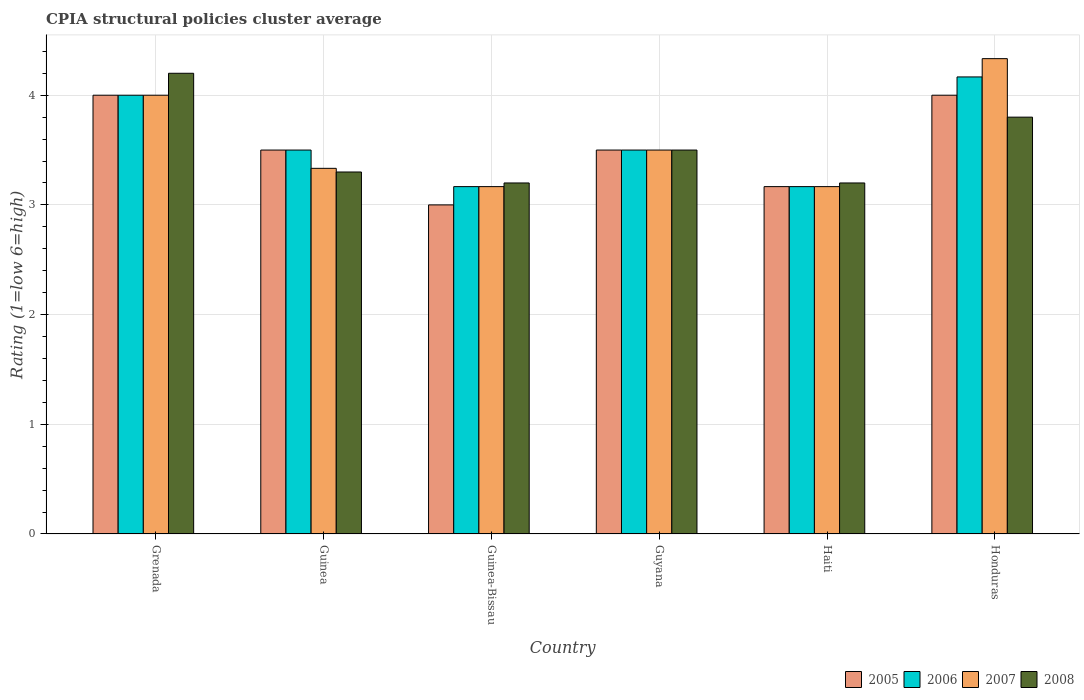How many groups of bars are there?
Your response must be concise. 6. Are the number of bars per tick equal to the number of legend labels?
Provide a succinct answer. Yes. Are the number of bars on each tick of the X-axis equal?
Provide a succinct answer. Yes. How many bars are there on the 5th tick from the left?
Make the answer very short. 4. How many bars are there on the 5th tick from the right?
Ensure brevity in your answer.  4. What is the label of the 3rd group of bars from the left?
Make the answer very short. Guinea-Bissau. In how many cases, is the number of bars for a given country not equal to the number of legend labels?
Make the answer very short. 0. What is the CPIA rating in 2005 in Grenada?
Your answer should be compact. 4. Across all countries, what is the minimum CPIA rating in 2007?
Give a very brief answer. 3.17. In which country was the CPIA rating in 2006 maximum?
Your response must be concise. Honduras. In which country was the CPIA rating in 2007 minimum?
Give a very brief answer. Guinea-Bissau. What is the total CPIA rating in 2005 in the graph?
Provide a short and direct response. 21.17. What is the difference between the CPIA rating in 2007 in Guinea and that in Honduras?
Provide a succinct answer. -1. What is the average CPIA rating in 2005 per country?
Offer a very short reply. 3.53. What is the difference between the CPIA rating of/in 2005 and CPIA rating of/in 2007 in Honduras?
Provide a succinct answer. -0.33. In how many countries, is the CPIA rating in 2006 greater than 2.6?
Make the answer very short. 6. What is the ratio of the CPIA rating in 2005 in Guinea-Bissau to that in Haiti?
Your answer should be very brief. 0.95. Is the CPIA rating in 2007 in Grenada less than that in Honduras?
Make the answer very short. Yes. Is the difference between the CPIA rating in 2005 in Guyana and Haiti greater than the difference between the CPIA rating in 2007 in Guyana and Haiti?
Offer a terse response. No. What is the difference between the highest and the second highest CPIA rating in 2008?
Offer a very short reply. -0.3. What is the difference between the highest and the lowest CPIA rating in 2007?
Offer a terse response. 1.17. In how many countries, is the CPIA rating in 2006 greater than the average CPIA rating in 2006 taken over all countries?
Give a very brief answer. 2. What does the 2nd bar from the left in Guyana represents?
Ensure brevity in your answer.  2006. Is it the case that in every country, the sum of the CPIA rating in 2005 and CPIA rating in 2006 is greater than the CPIA rating in 2008?
Your answer should be compact. Yes. How many bars are there?
Ensure brevity in your answer.  24. Are all the bars in the graph horizontal?
Offer a very short reply. No. How many countries are there in the graph?
Ensure brevity in your answer.  6. Are the values on the major ticks of Y-axis written in scientific E-notation?
Offer a terse response. No. Does the graph contain any zero values?
Provide a succinct answer. No. Does the graph contain grids?
Ensure brevity in your answer.  Yes. How are the legend labels stacked?
Your answer should be very brief. Horizontal. What is the title of the graph?
Your response must be concise. CPIA structural policies cluster average. What is the label or title of the X-axis?
Your answer should be very brief. Country. What is the Rating (1=low 6=high) in 2006 in Grenada?
Provide a short and direct response. 4. What is the Rating (1=low 6=high) of 2007 in Grenada?
Provide a succinct answer. 4. What is the Rating (1=low 6=high) in 2007 in Guinea?
Your answer should be compact. 3.33. What is the Rating (1=low 6=high) of 2005 in Guinea-Bissau?
Provide a succinct answer. 3. What is the Rating (1=low 6=high) in 2006 in Guinea-Bissau?
Provide a succinct answer. 3.17. What is the Rating (1=low 6=high) of 2007 in Guinea-Bissau?
Your response must be concise. 3.17. What is the Rating (1=low 6=high) of 2006 in Guyana?
Provide a succinct answer. 3.5. What is the Rating (1=low 6=high) of 2005 in Haiti?
Give a very brief answer. 3.17. What is the Rating (1=low 6=high) of 2006 in Haiti?
Ensure brevity in your answer.  3.17. What is the Rating (1=low 6=high) in 2007 in Haiti?
Keep it short and to the point. 3.17. What is the Rating (1=low 6=high) in 2008 in Haiti?
Your answer should be compact. 3.2. What is the Rating (1=low 6=high) in 2005 in Honduras?
Make the answer very short. 4. What is the Rating (1=low 6=high) of 2006 in Honduras?
Ensure brevity in your answer.  4.17. What is the Rating (1=low 6=high) of 2007 in Honduras?
Offer a terse response. 4.33. What is the Rating (1=low 6=high) in 2008 in Honduras?
Keep it short and to the point. 3.8. Across all countries, what is the maximum Rating (1=low 6=high) of 2005?
Provide a succinct answer. 4. Across all countries, what is the maximum Rating (1=low 6=high) of 2006?
Ensure brevity in your answer.  4.17. Across all countries, what is the maximum Rating (1=low 6=high) of 2007?
Your answer should be very brief. 4.33. Across all countries, what is the maximum Rating (1=low 6=high) of 2008?
Ensure brevity in your answer.  4.2. Across all countries, what is the minimum Rating (1=low 6=high) of 2005?
Offer a very short reply. 3. Across all countries, what is the minimum Rating (1=low 6=high) in 2006?
Make the answer very short. 3.17. Across all countries, what is the minimum Rating (1=low 6=high) in 2007?
Offer a very short reply. 3.17. What is the total Rating (1=low 6=high) in 2005 in the graph?
Keep it short and to the point. 21.17. What is the total Rating (1=low 6=high) in 2006 in the graph?
Your answer should be compact. 21.5. What is the total Rating (1=low 6=high) of 2007 in the graph?
Provide a short and direct response. 21.5. What is the total Rating (1=low 6=high) in 2008 in the graph?
Your answer should be very brief. 21.2. What is the difference between the Rating (1=low 6=high) of 2005 in Grenada and that in Guinea?
Offer a very short reply. 0.5. What is the difference between the Rating (1=low 6=high) in 2007 in Grenada and that in Guinea?
Offer a very short reply. 0.67. What is the difference between the Rating (1=low 6=high) of 2008 in Grenada and that in Guinea?
Give a very brief answer. 0.9. What is the difference between the Rating (1=low 6=high) in 2005 in Grenada and that in Guinea-Bissau?
Provide a succinct answer. 1. What is the difference between the Rating (1=low 6=high) in 2007 in Grenada and that in Guinea-Bissau?
Your answer should be compact. 0.83. What is the difference between the Rating (1=low 6=high) of 2005 in Grenada and that in Guyana?
Provide a succinct answer. 0.5. What is the difference between the Rating (1=low 6=high) of 2008 in Grenada and that in Guyana?
Your response must be concise. 0.7. What is the difference between the Rating (1=low 6=high) of 2005 in Grenada and that in Haiti?
Offer a terse response. 0.83. What is the difference between the Rating (1=low 6=high) of 2006 in Grenada and that in Haiti?
Provide a succinct answer. 0.83. What is the difference between the Rating (1=low 6=high) in 2007 in Grenada and that in Haiti?
Provide a succinct answer. 0.83. What is the difference between the Rating (1=low 6=high) of 2008 in Grenada and that in Honduras?
Your answer should be very brief. 0.4. What is the difference between the Rating (1=low 6=high) of 2005 in Guinea and that in Guinea-Bissau?
Your answer should be very brief. 0.5. What is the difference between the Rating (1=low 6=high) in 2006 in Guinea and that in Guinea-Bissau?
Keep it short and to the point. 0.33. What is the difference between the Rating (1=low 6=high) of 2006 in Guinea and that in Guyana?
Provide a succinct answer. 0. What is the difference between the Rating (1=low 6=high) of 2007 in Guinea and that in Guyana?
Give a very brief answer. -0.17. What is the difference between the Rating (1=low 6=high) in 2005 in Guinea and that in Haiti?
Offer a very short reply. 0.33. What is the difference between the Rating (1=low 6=high) in 2006 in Guinea and that in Haiti?
Provide a succinct answer. 0.33. What is the difference between the Rating (1=low 6=high) in 2007 in Guinea and that in Haiti?
Your response must be concise. 0.17. What is the difference between the Rating (1=low 6=high) in 2005 in Guinea and that in Honduras?
Keep it short and to the point. -0.5. What is the difference between the Rating (1=low 6=high) of 2005 in Guinea-Bissau and that in Guyana?
Make the answer very short. -0.5. What is the difference between the Rating (1=low 6=high) of 2007 in Guinea-Bissau and that in Guyana?
Your response must be concise. -0.33. What is the difference between the Rating (1=low 6=high) in 2006 in Guinea-Bissau and that in Haiti?
Offer a very short reply. 0. What is the difference between the Rating (1=low 6=high) in 2007 in Guinea-Bissau and that in Haiti?
Provide a succinct answer. 0. What is the difference between the Rating (1=low 6=high) in 2005 in Guinea-Bissau and that in Honduras?
Ensure brevity in your answer.  -1. What is the difference between the Rating (1=low 6=high) of 2006 in Guinea-Bissau and that in Honduras?
Offer a very short reply. -1. What is the difference between the Rating (1=low 6=high) in 2007 in Guinea-Bissau and that in Honduras?
Ensure brevity in your answer.  -1.17. What is the difference between the Rating (1=low 6=high) in 2008 in Guinea-Bissau and that in Honduras?
Your answer should be very brief. -0.6. What is the difference between the Rating (1=low 6=high) in 2005 in Guyana and that in Haiti?
Your answer should be very brief. 0.33. What is the difference between the Rating (1=low 6=high) in 2007 in Guyana and that in Haiti?
Make the answer very short. 0.33. What is the difference between the Rating (1=low 6=high) in 2005 in Haiti and that in Honduras?
Ensure brevity in your answer.  -0.83. What is the difference between the Rating (1=low 6=high) in 2006 in Haiti and that in Honduras?
Keep it short and to the point. -1. What is the difference between the Rating (1=low 6=high) in 2007 in Haiti and that in Honduras?
Provide a succinct answer. -1.17. What is the difference between the Rating (1=low 6=high) of 2005 in Grenada and the Rating (1=low 6=high) of 2007 in Guinea?
Give a very brief answer. 0.67. What is the difference between the Rating (1=low 6=high) of 2007 in Grenada and the Rating (1=low 6=high) of 2008 in Guinea?
Offer a very short reply. 0.7. What is the difference between the Rating (1=low 6=high) in 2005 in Grenada and the Rating (1=low 6=high) in 2006 in Guinea-Bissau?
Offer a terse response. 0.83. What is the difference between the Rating (1=low 6=high) in 2005 in Grenada and the Rating (1=low 6=high) in 2008 in Guinea-Bissau?
Ensure brevity in your answer.  0.8. What is the difference between the Rating (1=low 6=high) of 2006 in Grenada and the Rating (1=low 6=high) of 2008 in Guinea-Bissau?
Your answer should be compact. 0.8. What is the difference between the Rating (1=low 6=high) in 2005 in Grenada and the Rating (1=low 6=high) in 2006 in Guyana?
Provide a short and direct response. 0.5. What is the difference between the Rating (1=low 6=high) of 2005 in Grenada and the Rating (1=low 6=high) of 2008 in Guyana?
Offer a terse response. 0.5. What is the difference between the Rating (1=low 6=high) in 2005 in Grenada and the Rating (1=low 6=high) in 2008 in Haiti?
Provide a short and direct response. 0.8. What is the difference between the Rating (1=low 6=high) of 2006 in Grenada and the Rating (1=low 6=high) of 2008 in Haiti?
Offer a terse response. 0.8. What is the difference between the Rating (1=low 6=high) of 2006 in Grenada and the Rating (1=low 6=high) of 2007 in Honduras?
Give a very brief answer. -0.33. What is the difference between the Rating (1=low 6=high) in 2006 in Grenada and the Rating (1=low 6=high) in 2008 in Honduras?
Your answer should be compact. 0.2. What is the difference between the Rating (1=low 6=high) in 2007 in Grenada and the Rating (1=low 6=high) in 2008 in Honduras?
Your answer should be compact. 0.2. What is the difference between the Rating (1=low 6=high) of 2005 in Guinea and the Rating (1=low 6=high) of 2006 in Guinea-Bissau?
Your answer should be very brief. 0.33. What is the difference between the Rating (1=low 6=high) in 2005 in Guinea and the Rating (1=low 6=high) in 2007 in Guinea-Bissau?
Your response must be concise. 0.33. What is the difference between the Rating (1=low 6=high) in 2005 in Guinea and the Rating (1=low 6=high) in 2008 in Guinea-Bissau?
Your response must be concise. 0.3. What is the difference between the Rating (1=low 6=high) of 2006 in Guinea and the Rating (1=low 6=high) of 2007 in Guinea-Bissau?
Your answer should be compact. 0.33. What is the difference between the Rating (1=low 6=high) of 2006 in Guinea and the Rating (1=low 6=high) of 2008 in Guinea-Bissau?
Your answer should be compact. 0.3. What is the difference between the Rating (1=low 6=high) in 2007 in Guinea and the Rating (1=low 6=high) in 2008 in Guinea-Bissau?
Make the answer very short. 0.13. What is the difference between the Rating (1=low 6=high) in 2006 in Guinea and the Rating (1=low 6=high) in 2008 in Guyana?
Your answer should be very brief. 0. What is the difference between the Rating (1=low 6=high) of 2007 in Guinea and the Rating (1=low 6=high) of 2008 in Guyana?
Your answer should be compact. -0.17. What is the difference between the Rating (1=low 6=high) in 2005 in Guinea and the Rating (1=low 6=high) in 2007 in Haiti?
Your answer should be very brief. 0.33. What is the difference between the Rating (1=low 6=high) of 2005 in Guinea and the Rating (1=low 6=high) of 2008 in Haiti?
Your response must be concise. 0.3. What is the difference between the Rating (1=low 6=high) in 2006 in Guinea and the Rating (1=low 6=high) in 2007 in Haiti?
Offer a very short reply. 0.33. What is the difference between the Rating (1=low 6=high) of 2007 in Guinea and the Rating (1=low 6=high) of 2008 in Haiti?
Give a very brief answer. 0.13. What is the difference between the Rating (1=low 6=high) in 2005 in Guinea and the Rating (1=low 6=high) in 2006 in Honduras?
Your answer should be compact. -0.67. What is the difference between the Rating (1=low 6=high) of 2005 in Guinea and the Rating (1=low 6=high) of 2007 in Honduras?
Make the answer very short. -0.83. What is the difference between the Rating (1=low 6=high) of 2005 in Guinea and the Rating (1=low 6=high) of 2008 in Honduras?
Give a very brief answer. -0.3. What is the difference between the Rating (1=low 6=high) in 2006 in Guinea and the Rating (1=low 6=high) in 2008 in Honduras?
Offer a terse response. -0.3. What is the difference between the Rating (1=low 6=high) of 2007 in Guinea and the Rating (1=low 6=high) of 2008 in Honduras?
Provide a short and direct response. -0.47. What is the difference between the Rating (1=low 6=high) in 2005 in Guinea-Bissau and the Rating (1=low 6=high) in 2007 in Guyana?
Your answer should be compact. -0.5. What is the difference between the Rating (1=low 6=high) of 2006 in Guinea-Bissau and the Rating (1=low 6=high) of 2008 in Guyana?
Your response must be concise. -0.33. What is the difference between the Rating (1=low 6=high) in 2005 in Guinea-Bissau and the Rating (1=low 6=high) in 2007 in Haiti?
Make the answer very short. -0.17. What is the difference between the Rating (1=low 6=high) of 2006 in Guinea-Bissau and the Rating (1=low 6=high) of 2008 in Haiti?
Your answer should be very brief. -0.03. What is the difference between the Rating (1=low 6=high) in 2007 in Guinea-Bissau and the Rating (1=low 6=high) in 2008 in Haiti?
Provide a succinct answer. -0.03. What is the difference between the Rating (1=low 6=high) of 2005 in Guinea-Bissau and the Rating (1=low 6=high) of 2006 in Honduras?
Make the answer very short. -1.17. What is the difference between the Rating (1=low 6=high) of 2005 in Guinea-Bissau and the Rating (1=low 6=high) of 2007 in Honduras?
Ensure brevity in your answer.  -1.33. What is the difference between the Rating (1=low 6=high) of 2006 in Guinea-Bissau and the Rating (1=low 6=high) of 2007 in Honduras?
Your response must be concise. -1.17. What is the difference between the Rating (1=low 6=high) in 2006 in Guinea-Bissau and the Rating (1=low 6=high) in 2008 in Honduras?
Provide a succinct answer. -0.63. What is the difference between the Rating (1=low 6=high) in 2007 in Guinea-Bissau and the Rating (1=low 6=high) in 2008 in Honduras?
Keep it short and to the point. -0.63. What is the difference between the Rating (1=low 6=high) in 2005 in Guyana and the Rating (1=low 6=high) in 2006 in Haiti?
Provide a short and direct response. 0.33. What is the difference between the Rating (1=low 6=high) of 2005 in Guyana and the Rating (1=low 6=high) of 2007 in Haiti?
Your answer should be compact. 0.33. What is the difference between the Rating (1=low 6=high) in 2005 in Guyana and the Rating (1=low 6=high) in 2008 in Haiti?
Offer a very short reply. 0.3. What is the difference between the Rating (1=low 6=high) in 2006 in Guyana and the Rating (1=low 6=high) in 2007 in Haiti?
Ensure brevity in your answer.  0.33. What is the difference between the Rating (1=low 6=high) of 2005 in Guyana and the Rating (1=low 6=high) of 2007 in Honduras?
Your answer should be compact. -0.83. What is the difference between the Rating (1=low 6=high) in 2006 in Guyana and the Rating (1=low 6=high) in 2007 in Honduras?
Offer a terse response. -0.83. What is the difference between the Rating (1=low 6=high) in 2006 in Guyana and the Rating (1=low 6=high) in 2008 in Honduras?
Your answer should be very brief. -0.3. What is the difference between the Rating (1=low 6=high) of 2005 in Haiti and the Rating (1=low 6=high) of 2007 in Honduras?
Provide a succinct answer. -1.17. What is the difference between the Rating (1=low 6=high) in 2005 in Haiti and the Rating (1=low 6=high) in 2008 in Honduras?
Your response must be concise. -0.63. What is the difference between the Rating (1=low 6=high) in 2006 in Haiti and the Rating (1=low 6=high) in 2007 in Honduras?
Your response must be concise. -1.17. What is the difference between the Rating (1=low 6=high) of 2006 in Haiti and the Rating (1=low 6=high) of 2008 in Honduras?
Your answer should be compact. -0.63. What is the difference between the Rating (1=low 6=high) in 2007 in Haiti and the Rating (1=low 6=high) in 2008 in Honduras?
Offer a very short reply. -0.63. What is the average Rating (1=low 6=high) in 2005 per country?
Keep it short and to the point. 3.53. What is the average Rating (1=low 6=high) of 2006 per country?
Your response must be concise. 3.58. What is the average Rating (1=low 6=high) of 2007 per country?
Provide a short and direct response. 3.58. What is the average Rating (1=low 6=high) of 2008 per country?
Your answer should be compact. 3.53. What is the difference between the Rating (1=low 6=high) in 2005 and Rating (1=low 6=high) in 2007 in Grenada?
Your response must be concise. 0. What is the difference between the Rating (1=low 6=high) of 2005 and Rating (1=low 6=high) of 2008 in Grenada?
Your answer should be compact. -0.2. What is the difference between the Rating (1=low 6=high) of 2006 and Rating (1=low 6=high) of 2007 in Grenada?
Ensure brevity in your answer.  0. What is the difference between the Rating (1=low 6=high) in 2007 and Rating (1=low 6=high) in 2008 in Grenada?
Your response must be concise. -0.2. What is the difference between the Rating (1=low 6=high) in 2005 and Rating (1=low 6=high) in 2006 in Guinea?
Your answer should be compact. 0. What is the difference between the Rating (1=low 6=high) of 2006 and Rating (1=low 6=high) of 2007 in Guinea?
Your answer should be very brief. 0.17. What is the difference between the Rating (1=low 6=high) in 2006 and Rating (1=low 6=high) in 2008 in Guinea?
Your response must be concise. 0.2. What is the difference between the Rating (1=low 6=high) in 2007 and Rating (1=low 6=high) in 2008 in Guinea?
Keep it short and to the point. 0.03. What is the difference between the Rating (1=low 6=high) in 2005 and Rating (1=low 6=high) in 2007 in Guinea-Bissau?
Ensure brevity in your answer.  -0.17. What is the difference between the Rating (1=low 6=high) of 2005 and Rating (1=low 6=high) of 2008 in Guinea-Bissau?
Offer a very short reply. -0.2. What is the difference between the Rating (1=low 6=high) in 2006 and Rating (1=low 6=high) in 2008 in Guinea-Bissau?
Provide a short and direct response. -0.03. What is the difference between the Rating (1=low 6=high) in 2007 and Rating (1=low 6=high) in 2008 in Guinea-Bissau?
Your answer should be very brief. -0.03. What is the difference between the Rating (1=low 6=high) of 2005 and Rating (1=low 6=high) of 2007 in Guyana?
Provide a succinct answer. 0. What is the difference between the Rating (1=low 6=high) in 2005 and Rating (1=low 6=high) in 2008 in Guyana?
Offer a terse response. 0. What is the difference between the Rating (1=low 6=high) in 2005 and Rating (1=low 6=high) in 2006 in Haiti?
Provide a succinct answer. 0. What is the difference between the Rating (1=low 6=high) of 2005 and Rating (1=low 6=high) of 2008 in Haiti?
Ensure brevity in your answer.  -0.03. What is the difference between the Rating (1=low 6=high) of 2006 and Rating (1=low 6=high) of 2008 in Haiti?
Your answer should be very brief. -0.03. What is the difference between the Rating (1=low 6=high) in 2007 and Rating (1=low 6=high) in 2008 in Haiti?
Provide a short and direct response. -0.03. What is the difference between the Rating (1=low 6=high) of 2005 and Rating (1=low 6=high) of 2007 in Honduras?
Your response must be concise. -0.33. What is the difference between the Rating (1=low 6=high) in 2006 and Rating (1=low 6=high) in 2008 in Honduras?
Offer a terse response. 0.37. What is the difference between the Rating (1=low 6=high) of 2007 and Rating (1=low 6=high) of 2008 in Honduras?
Give a very brief answer. 0.53. What is the ratio of the Rating (1=low 6=high) of 2006 in Grenada to that in Guinea?
Your answer should be compact. 1.14. What is the ratio of the Rating (1=low 6=high) of 2008 in Grenada to that in Guinea?
Offer a terse response. 1.27. What is the ratio of the Rating (1=low 6=high) in 2006 in Grenada to that in Guinea-Bissau?
Provide a short and direct response. 1.26. What is the ratio of the Rating (1=low 6=high) of 2007 in Grenada to that in Guinea-Bissau?
Offer a terse response. 1.26. What is the ratio of the Rating (1=low 6=high) of 2008 in Grenada to that in Guinea-Bissau?
Provide a succinct answer. 1.31. What is the ratio of the Rating (1=low 6=high) in 2005 in Grenada to that in Haiti?
Give a very brief answer. 1.26. What is the ratio of the Rating (1=low 6=high) of 2006 in Grenada to that in Haiti?
Your answer should be compact. 1.26. What is the ratio of the Rating (1=low 6=high) of 2007 in Grenada to that in Haiti?
Make the answer very short. 1.26. What is the ratio of the Rating (1=low 6=high) of 2008 in Grenada to that in Haiti?
Keep it short and to the point. 1.31. What is the ratio of the Rating (1=low 6=high) in 2006 in Grenada to that in Honduras?
Your answer should be very brief. 0.96. What is the ratio of the Rating (1=low 6=high) in 2007 in Grenada to that in Honduras?
Provide a succinct answer. 0.92. What is the ratio of the Rating (1=low 6=high) in 2008 in Grenada to that in Honduras?
Ensure brevity in your answer.  1.11. What is the ratio of the Rating (1=low 6=high) of 2005 in Guinea to that in Guinea-Bissau?
Make the answer very short. 1.17. What is the ratio of the Rating (1=low 6=high) in 2006 in Guinea to that in Guinea-Bissau?
Your answer should be very brief. 1.11. What is the ratio of the Rating (1=low 6=high) in 2007 in Guinea to that in Guinea-Bissau?
Your answer should be very brief. 1.05. What is the ratio of the Rating (1=low 6=high) in 2008 in Guinea to that in Guinea-Bissau?
Give a very brief answer. 1.03. What is the ratio of the Rating (1=low 6=high) of 2005 in Guinea to that in Guyana?
Provide a succinct answer. 1. What is the ratio of the Rating (1=low 6=high) in 2006 in Guinea to that in Guyana?
Make the answer very short. 1. What is the ratio of the Rating (1=low 6=high) in 2007 in Guinea to that in Guyana?
Provide a succinct answer. 0.95. What is the ratio of the Rating (1=low 6=high) of 2008 in Guinea to that in Guyana?
Give a very brief answer. 0.94. What is the ratio of the Rating (1=low 6=high) in 2005 in Guinea to that in Haiti?
Your answer should be compact. 1.11. What is the ratio of the Rating (1=low 6=high) of 2006 in Guinea to that in Haiti?
Ensure brevity in your answer.  1.11. What is the ratio of the Rating (1=low 6=high) in 2007 in Guinea to that in Haiti?
Offer a terse response. 1.05. What is the ratio of the Rating (1=low 6=high) of 2008 in Guinea to that in Haiti?
Offer a very short reply. 1.03. What is the ratio of the Rating (1=low 6=high) of 2006 in Guinea to that in Honduras?
Your answer should be compact. 0.84. What is the ratio of the Rating (1=low 6=high) of 2007 in Guinea to that in Honduras?
Offer a very short reply. 0.77. What is the ratio of the Rating (1=low 6=high) in 2008 in Guinea to that in Honduras?
Provide a succinct answer. 0.87. What is the ratio of the Rating (1=low 6=high) in 2005 in Guinea-Bissau to that in Guyana?
Ensure brevity in your answer.  0.86. What is the ratio of the Rating (1=low 6=high) in 2006 in Guinea-Bissau to that in Guyana?
Offer a very short reply. 0.9. What is the ratio of the Rating (1=low 6=high) of 2007 in Guinea-Bissau to that in Guyana?
Offer a terse response. 0.9. What is the ratio of the Rating (1=low 6=high) of 2008 in Guinea-Bissau to that in Guyana?
Provide a short and direct response. 0.91. What is the ratio of the Rating (1=low 6=high) of 2006 in Guinea-Bissau to that in Haiti?
Ensure brevity in your answer.  1. What is the ratio of the Rating (1=low 6=high) in 2005 in Guinea-Bissau to that in Honduras?
Make the answer very short. 0.75. What is the ratio of the Rating (1=low 6=high) of 2006 in Guinea-Bissau to that in Honduras?
Your answer should be compact. 0.76. What is the ratio of the Rating (1=low 6=high) in 2007 in Guinea-Bissau to that in Honduras?
Keep it short and to the point. 0.73. What is the ratio of the Rating (1=low 6=high) in 2008 in Guinea-Bissau to that in Honduras?
Provide a succinct answer. 0.84. What is the ratio of the Rating (1=low 6=high) of 2005 in Guyana to that in Haiti?
Make the answer very short. 1.11. What is the ratio of the Rating (1=low 6=high) in 2006 in Guyana to that in Haiti?
Keep it short and to the point. 1.11. What is the ratio of the Rating (1=low 6=high) in 2007 in Guyana to that in Haiti?
Provide a short and direct response. 1.11. What is the ratio of the Rating (1=low 6=high) in 2008 in Guyana to that in Haiti?
Offer a terse response. 1.09. What is the ratio of the Rating (1=low 6=high) of 2006 in Guyana to that in Honduras?
Make the answer very short. 0.84. What is the ratio of the Rating (1=low 6=high) in 2007 in Guyana to that in Honduras?
Keep it short and to the point. 0.81. What is the ratio of the Rating (1=low 6=high) of 2008 in Guyana to that in Honduras?
Ensure brevity in your answer.  0.92. What is the ratio of the Rating (1=low 6=high) in 2005 in Haiti to that in Honduras?
Ensure brevity in your answer.  0.79. What is the ratio of the Rating (1=low 6=high) of 2006 in Haiti to that in Honduras?
Your answer should be very brief. 0.76. What is the ratio of the Rating (1=low 6=high) in 2007 in Haiti to that in Honduras?
Offer a very short reply. 0.73. What is the ratio of the Rating (1=low 6=high) in 2008 in Haiti to that in Honduras?
Your response must be concise. 0.84. What is the difference between the highest and the second highest Rating (1=low 6=high) of 2007?
Your answer should be very brief. 0.33. What is the difference between the highest and the second highest Rating (1=low 6=high) of 2008?
Offer a very short reply. 0.4. What is the difference between the highest and the lowest Rating (1=low 6=high) of 2007?
Your answer should be compact. 1.17. What is the difference between the highest and the lowest Rating (1=low 6=high) of 2008?
Offer a very short reply. 1. 